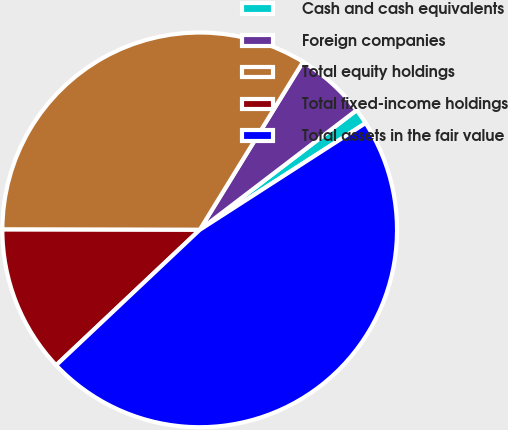Convert chart to OTSL. <chart><loc_0><loc_0><loc_500><loc_500><pie_chart><fcel>Cash and cash equivalents<fcel>Foreign companies<fcel>Total equity holdings<fcel>Total fixed-income holdings<fcel>Total assets in the fair value<nl><fcel>1.27%<fcel>5.85%<fcel>33.75%<fcel>12.06%<fcel>47.07%<nl></chart> 